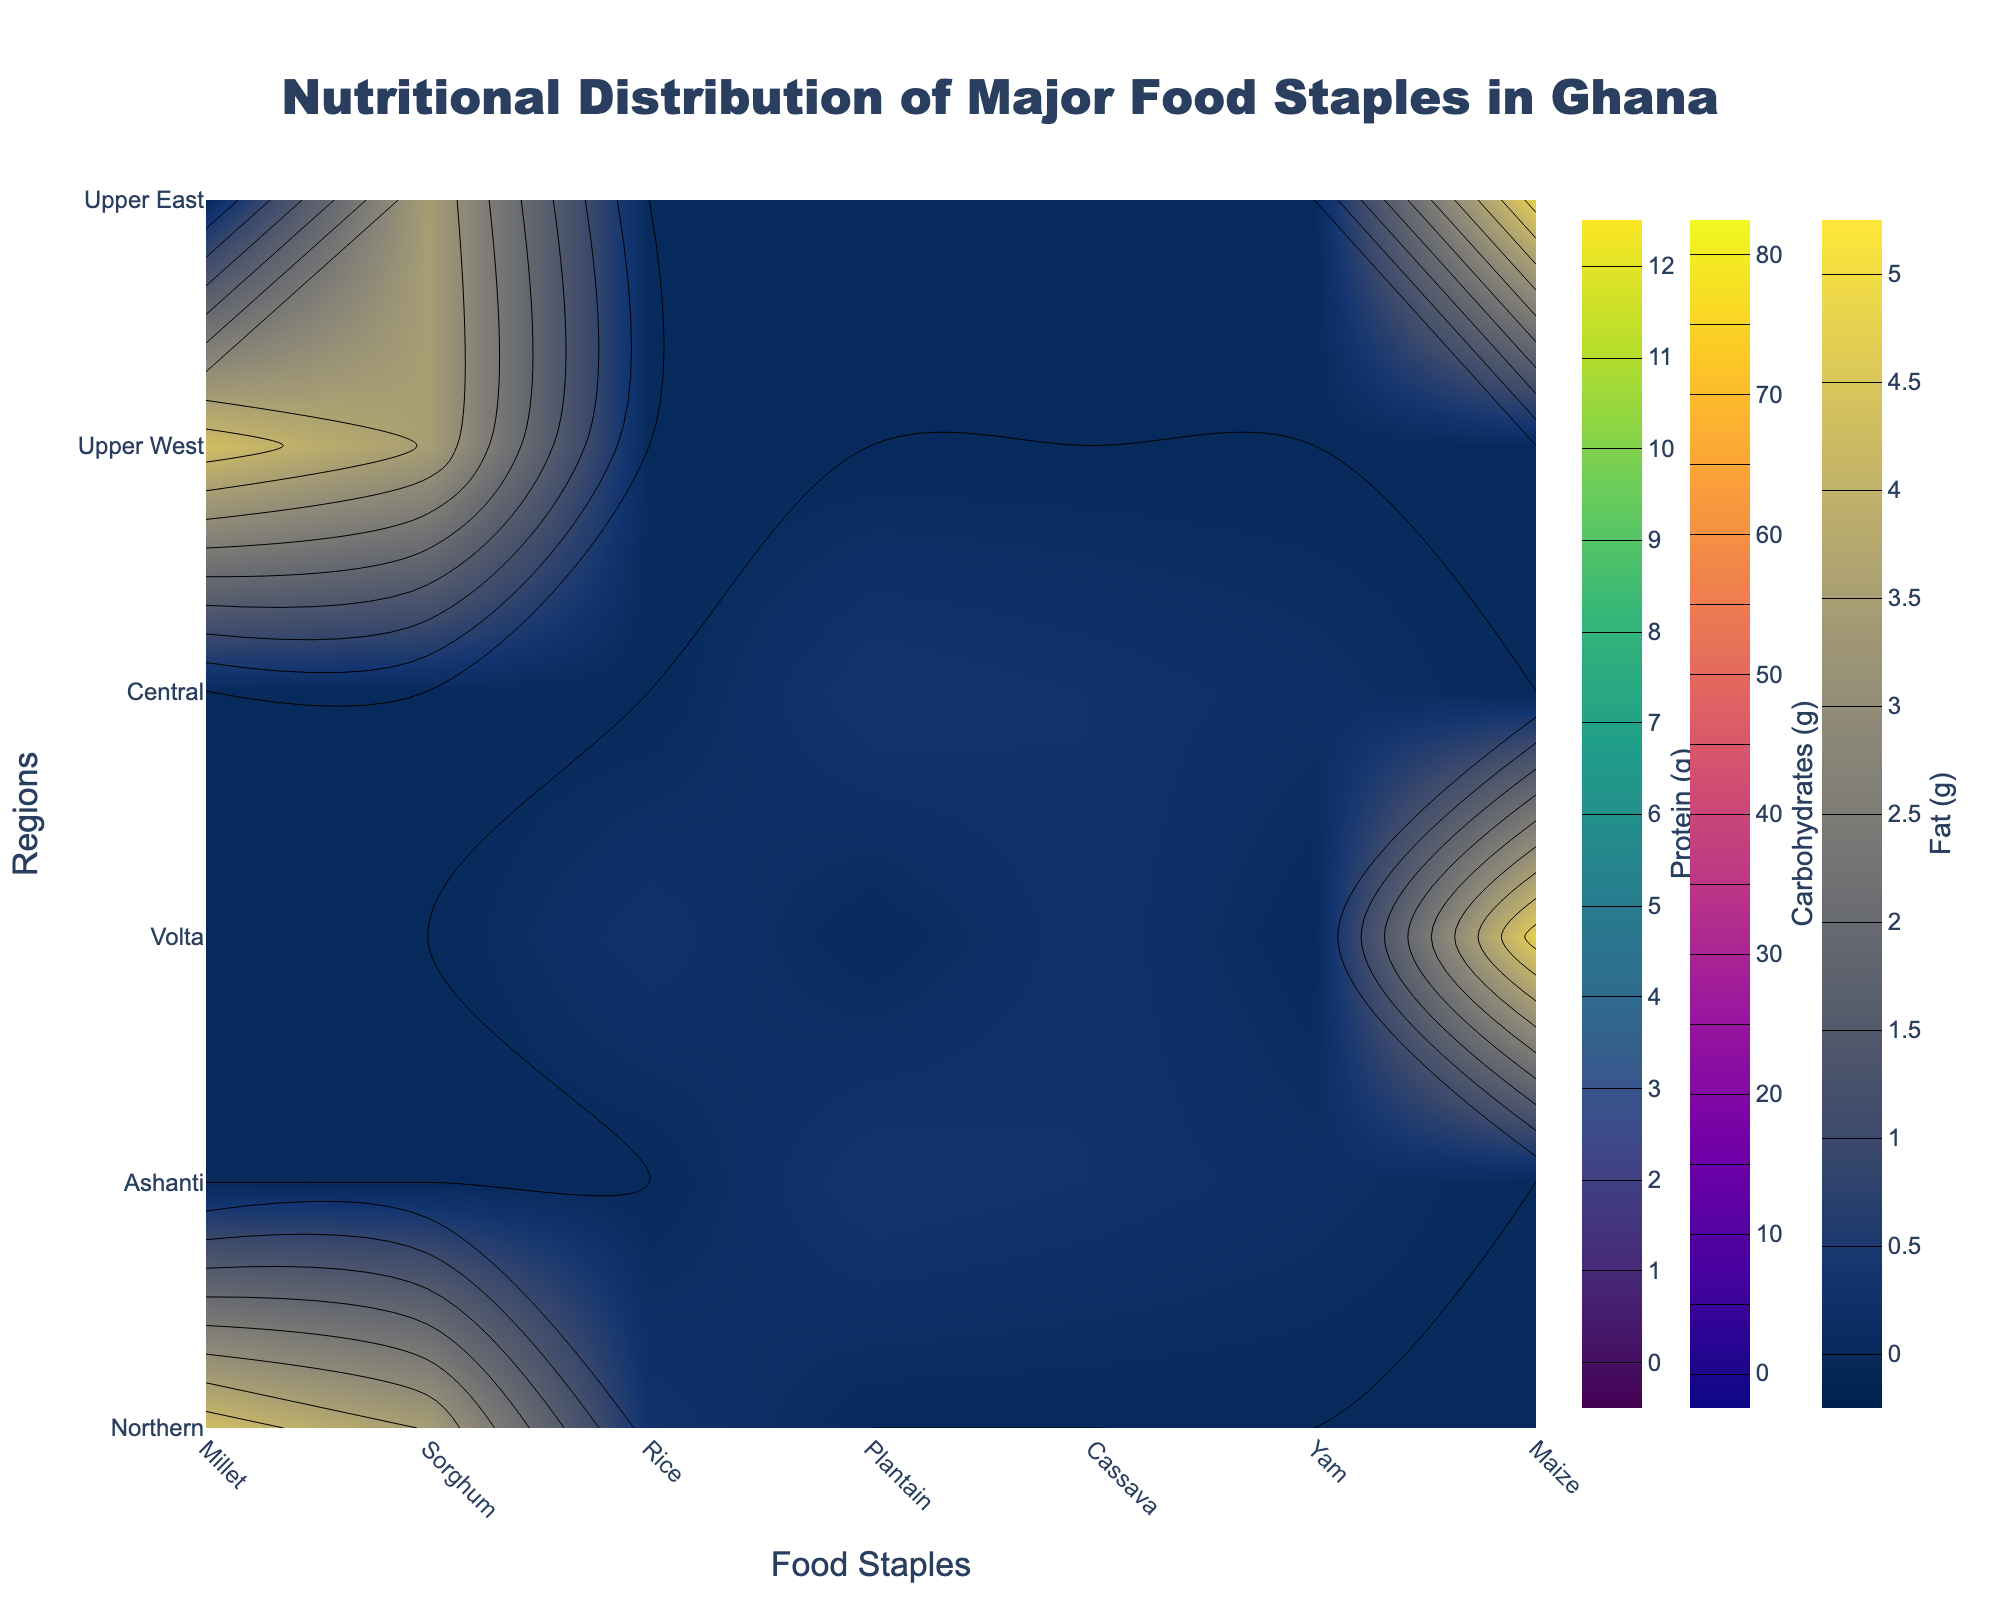Which food staple has the highest protein content in the Northern region? Look for the contour lines on the plot specifically for the Northern region and identify the highest point in the protein contour. The highest protein content corresponds to Millet and Sorghum, both around 11.42g and 11.30g respectively.
Answer: Millet What is the overall carbohydrate content for maize in the regions where it is present? Sum up the carbohydrate values for maize present in the Volta and Upper East regions. The values are 74.26g for both regions. 74.26g + 74.26g = 148.52g.
Answer: 148.52g Which region has the highest average fat content across its major food staples? Calculate the average fat content for each region and compare. Northern has Millet (4.29g), Sorghum (3.46g), Rice (0.28g); average is (4.29+3.46+0.28)/3 = 2.676g. Ashanti has Plantain (0.37g), Cassava (0.28g), Yam (0.17g); average is (0.37+0.28+0.17)/3 = 0.274g. Volta has Maize (4.74g), Rice (0.28g), Cassava (0.28g); average is (4.74+0.28+0.28)/3 = 1.766g. Central has Plantain (0.37g), Cassava (0.28g), Yam (0.17g); average is (0.37+0.28+0.17)/3 = 0.274g. Upper West has Millet (4.29g), Sorghum (3.46g); average is (4.29+3.46)/2 = 3.875g. Upper East has Maize (4.74g), Sorghum (3.46g); average is (4.74+3.46)/2 = 4.1g. The region with the highest average is Upper East.
Answer: Upper East Compare the protein content of Sorghum in the Northern and Upper East regions. Which region has higher protein content? Look at the protein contour levels for Sorghum in the Northern and Upper East regions. Sorghum has the same protein content (11.30g) in both regions.
Answer: Equal Which food staple in Ashanti has the highest carbohydrate content? Look for the food staples in the Ashanti region and compare their carbohydrate contours. The highest carbohydrate content corresponds to Cassava with 38.06g.
Answer: Cassava Which region has the lowest protein content for rice? Identify the protein content for rice in the regions it is present (Northern and Volta). Both have 2.38g, so they are equal.
Answer: Equal What is the difference in fat content between Maize in the Volta and Upper East regions? Look at the fat content for Maize in the Volta and Upper East regions. Both have 4.74g, so the difference is 0g.
Answer: 0g Which food staple has the highest average nutrient content overall (considering protein, carbohydrates, and fat)? To find the highest average nutrient content, sum up the nutrients for each food staple and compare the average. Millet: (11.42 + 72.85 + 4.29)/3 = 29.52g, Sorghum: (11.30 + 72.64 + 3.46)/3 = 29.13g, Rice: (2.38 + 28.17 + 0.28)/3 = 10.28g, Plantain: (3.63 + 32.53 + 0.37)/3 = 12.84g, Cassava: (1.36 + 38.06 + 0.28)/3 = 13.23g, Yam: (1.53 + 27.88 + 0.17)/3 = 9.86g, Maize: (9.42 + 74.26 + 4.74)/3 = 29.47g. The highest average nutrient content is in Millet.
Answer: Millet 